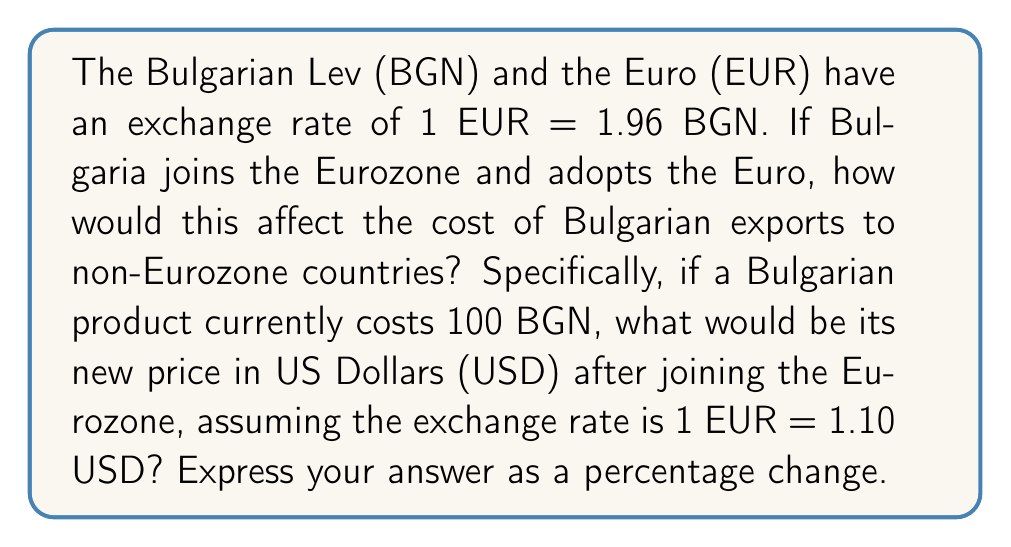Give your solution to this math problem. Let's approach this step-by-step:

1) First, let's calculate the current price of the product in EUR:
   $$100 \text{ BGN} \times \frac{1 \text{ EUR}}{1.96 \text{ BGN}} = 51.02 \text{ EUR}$$

2) Now, let's convert this to USD using the given exchange rate:
   $$51.02 \text{ EUR} \times \frac{1.10 \text{ USD}}{1 \text{ EUR}} = 56.12 \text{ USD}$$

3) After joining the Eurozone, the price would be 100 EUR (as 100 BGN becomes 100 EUR).

4) Let's convert this new price to USD:
   $$100 \text{ EUR} \times \frac{1.10 \text{ USD}}{1 \text{ EUR}} = 110 \text{ USD}$$

5) To calculate the percentage change:
   $$\text{Percentage Change} = \frac{\text{New Value} - \text{Original Value}}{\text{Original Value}} \times 100\%$$
   $$= \frac{110 - 56.12}{56.12} \times 100\% = 96.01\%$$

Therefore, the price of Bulgarian exports would increase by approximately 96.01% in USD terms after joining the Eurozone.
Answer: 96.01% increase 